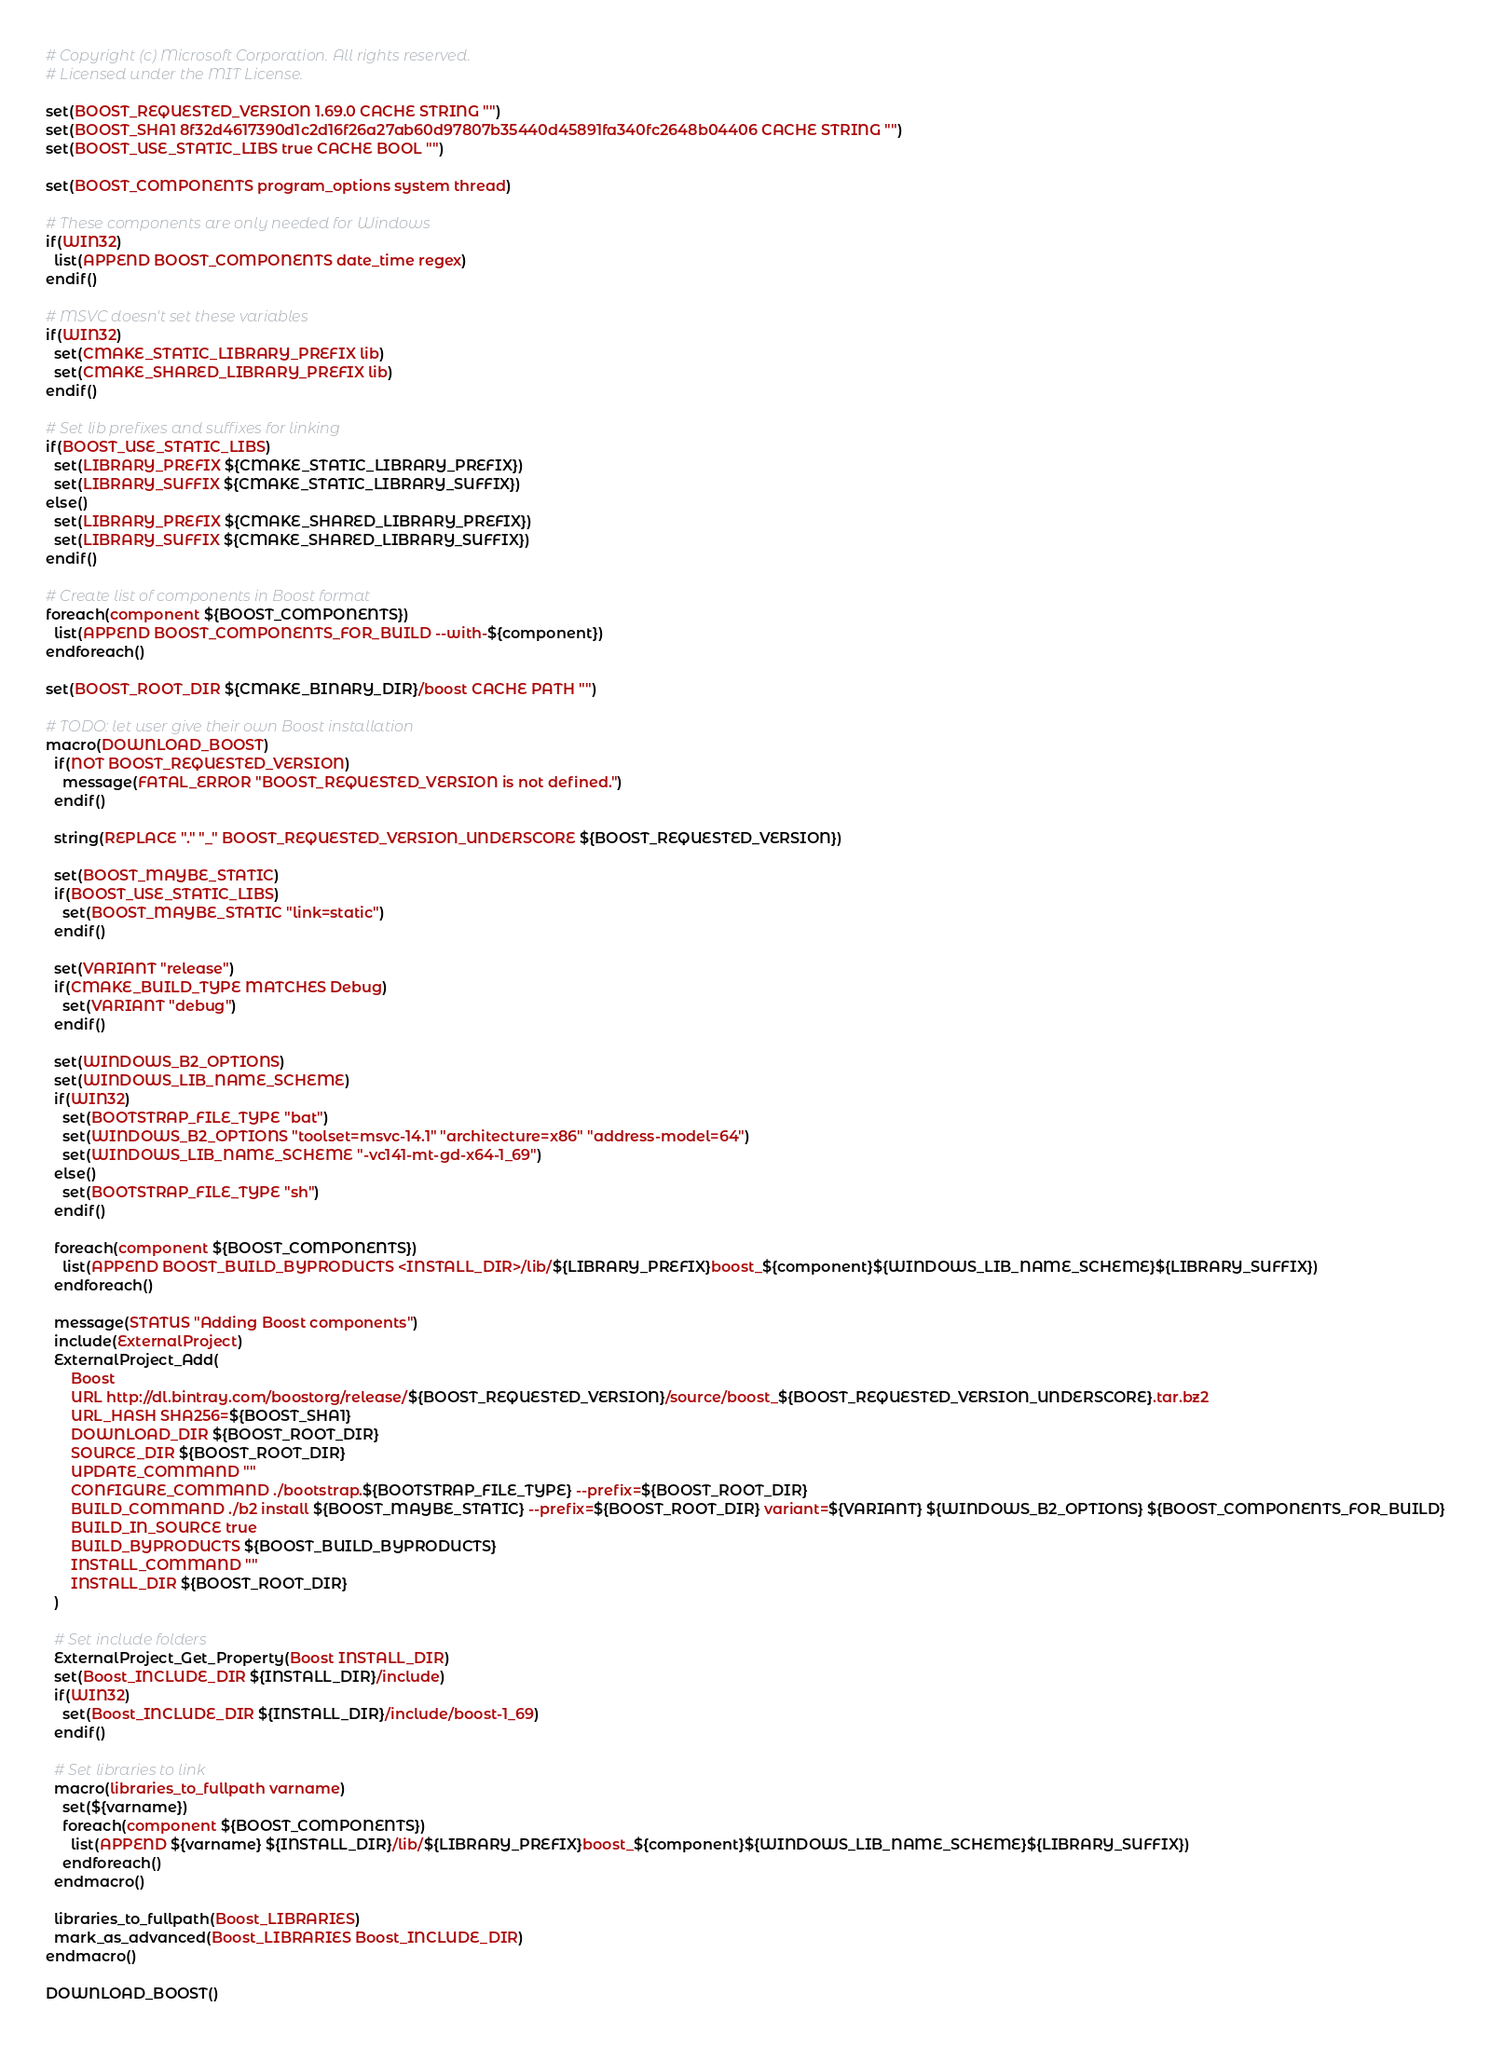Convert code to text. <code><loc_0><loc_0><loc_500><loc_500><_CMake_># Copyright (c) Microsoft Corporation. All rights reserved.
# Licensed under the MIT License.

set(BOOST_REQUESTED_VERSION 1.69.0 CACHE STRING "")
set(BOOST_SHA1 8f32d4617390d1c2d16f26a27ab60d97807b35440d45891fa340fc2648b04406 CACHE STRING "")
set(BOOST_USE_STATIC_LIBS true CACHE BOOL "")

set(BOOST_COMPONENTS program_options system thread)

# These components are only needed for Windows
if(WIN32)
  list(APPEND BOOST_COMPONENTS date_time regex)
endif()

# MSVC doesn't set these variables
if(WIN32)
  set(CMAKE_STATIC_LIBRARY_PREFIX lib)
  set(CMAKE_SHARED_LIBRARY_PREFIX lib)
endif()

# Set lib prefixes and suffixes for linking
if(BOOST_USE_STATIC_LIBS)
  set(LIBRARY_PREFIX ${CMAKE_STATIC_LIBRARY_PREFIX})
  set(LIBRARY_SUFFIX ${CMAKE_STATIC_LIBRARY_SUFFIX})
else()
  set(LIBRARY_PREFIX ${CMAKE_SHARED_LIBRARY_PREFIX})
  set(LIBRARY_SUFFIX ${CMAKE_SHARED_LIBRARY_SUFFIX})
endif()

# Create list of components in Boost format
foreach(component ${BOOST_COMPONENTS})
  list(APPEND BOOST_COMPONENTS_FOR_BUILD --with-${component})
endforeach()

set(BOOST_ROOT_DIR ${CMAKE_BINARY_DIR}/boost CACHE PATH "")

# TODO: let user give their own Boost installation
macro(DOWNLOAD_BOOST)
  if(NOT BOOST_REQUESTED_VERSION)
    message(FATAL_ERROR "BOOST_REQUESTED_VERSION is not defined.")
  endif()

  string(REPLACE "." "_" BOOST_REQUESTED_VERSION_UNDERSCORE ${BOOST_REQUESTED_VERSION})

  set(BOOST_MAYBE_STATIC)
  if(BOOST_USE_STATIC_LIBS)
    set(BOOST_MAYBE_STATIC "link=static")
  endif()

  set(VARIANT "release")
  if(CMAKE_BUILD_TYPE MATCHES Debug)
    set(VARIANT "debug")
  endif()

  set(WINDOWS_B2_OPTIONS)
  set(WINDOWS_LIB_NAME_SCHEME)
  if(WIN32)
    set(BOOTSTRAP_FILE_TYPE "bat")
    set(WINDOWS_B2_OPTIONS "toolset=msvc-14.1" "architecture=x86" "address-model=64")
    set(WINDOWS_LIB_NAME_SCHEME "-vc141-mt-gd-x64-1_69")
  else()
    set(BOOTSTRAP_FILE_TYPE "sh")
  endif()

  foreach(component ${BOOST_COMPONENTS})
    list(APPEND BOOST_BUILD_BYPRODUCTS <INSTALL_DIR>/lib/${LIBRARY_PREFIX}boost_${component}${WINDOWS_LIB_NAME_SCHEME}${LIBRARY_SUFFIX})
  endforeach()

  message(STATUS "Adding Boost components")
  include(ExternalProject)
  ExternalProject_Add(
      Boost
      URL http://dl.bintray.com/boostorg/release/${BOOST_REQUESTED_VERSION}/source/boost_${BOOST_REQUESTED_VERSION_UNDERSCORE}.tar.bz2
      URL_HASH SHA256=${BOOST_SHA1}
      DOWNLOAD_DIR ${BOOST_ROOT_DIR}
      SOURCE_DIR ${BOOST_ROOT_DIR}
      UPDATE_COMMAND ""
      CONFIGURE_COMMAND ./bootstrap.${BOOTSTRAP_FILE_TYPE} --prefix=${BOOST_ROOT_DIR}
      BUILD_COMMAND ./b2 install ${BOOST_MAYBE_STATIC} --prefix=${BOOST_ROOT_DIR} variant=${VARIANT} ${WINDOWS_B2_OPTIONS} ${BOOST_COMPONENTS_FOR_BUILD}
      BUILD_IN_SOURCE true
      BUILD_BYPRODUCTS ${BOOST_BUILD_BYPRODUCTS}
      INSTALL_COMMAND ""
      INSTALL_DIR ${BOOST_ROOT_DIR}
  )

  # Set include folders
  ExternalProject_Get_Property(Boost INSTALL_DIR)
  set(Boost_INCLUDE_DIR ${INSTALL_DIR}/include)
  if(WIN32)
    set(Boost_INCLUDE_DIR ${INSTALL_DIR}/include/boost-1_69)
  endif()

  # Set libraries to link
  macro(libraries_to_fullpath varname)
    set(${varname})
    foreach(component ${BOOST_COMPONENTS})
      list(APPEND ${varname} ${INSTALL_DIR}/lib/${LIBRARY_PREFIX}boost_${component}${WINDOWS_LIB_NAME_SCHEME}${LIBRARY_SUFFIX})
    endforeach()
  endmacro()

  libraries_to_fullpath(Boost_LIBRARIES)
  mark_as_advanced(Boost_LIBRARIES Boost_INCLUDE_DIR)
endmacro()

DOWNLOAD_BOOST()
</code> 